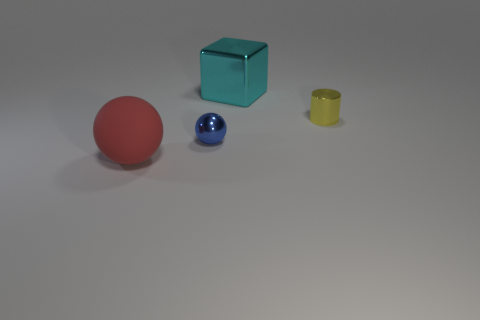Which object seems smallest and why do you think it appears that way? The smallest object appears to be the blue sphere. This perception is likely due to its size relative to the other objects and its placement in the image, potentially conveying depth and perspective. 